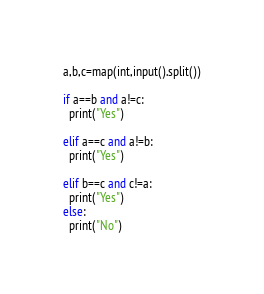<code> <loc_0><loc_0><loc_500><loc_500><_Python_>a,b,c=map(int,input().split())

if a==b and a!=c:
  print("Yes")

elif a==c and a!=b:
  print("Yes")

elif b==c and c!=a:
  print("Yes")
else:
  print("No")</code> 